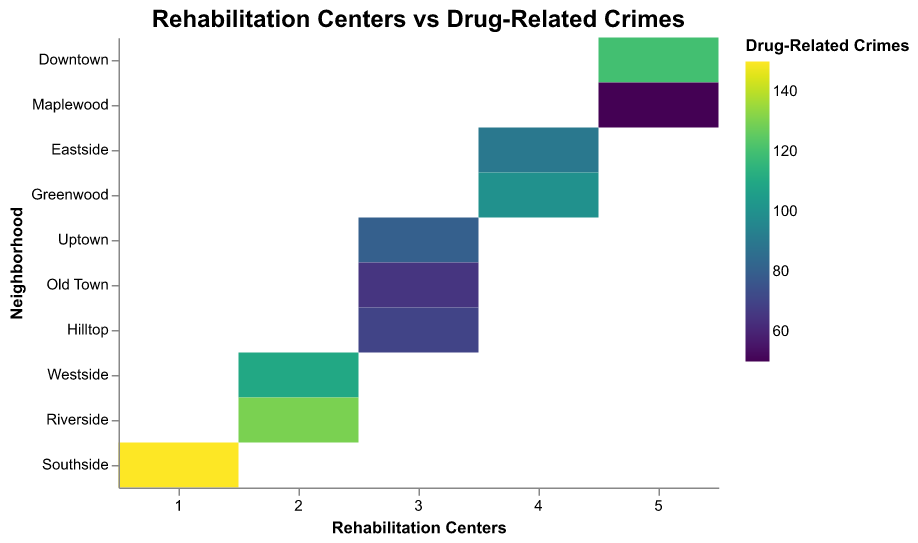what is the title of the heatmap? The title is displayed at the top of the heatmap and is centered. It provides the overarching theme or the main focus of the heatmap.
Answer: Rehabilitation Centers vs Drug-Related Crimes Which neighborhood has the highest number of rehabilitation centers? By referring to the y-axis representing neighborhoods and the x-axis indicating the number of rehabilitation centers, we see the highest value.
Answer: Downtown and Maplewood, each with 5 centers What is the color legend about? The color legend shows the gradient used in the heatmap to represent the range of drug-related crimes, with different shades indicating varying crime rates.
Answer: Drug-Related Crimes How many neighborhoods have exactly 3 rehabilitation centers? By examining the neighborhoods column and counting those with three rehabilitation centers, which can easily be seen on the x-axis, we can determine the number.
Answer: 3 (Uptown, Old Town, and Hilltop) Which neighborhoods have more than 100 drug-related crimes? By identifying the color intensity on the heatmap representing high crime rates and cross-referencing with the y-axis for neighborhood names, we find the neighborhoods with high crime rates.
Answer: Downtown, Westside, Southside, Riverside Does having more rehabilitation centers correlate with fewer drug-related crimes? Observing the heatmap, one can compare neighborhoods with higher numbers of centers and their respective crime rates to judge correlations. For example, Downtown and Maplewood have high and low crime rates respectively despite having the same number of rehabilitation centers.
Answer: No clear correlation What's the difference in drug-related crime numbers between Riverside and Hilltop? Locate Riverside and Hilltop on the y-axis and refer to their corresponding crime rates on the color scale. The subtraction of these values provides the difference.
Answer: 130 - 70 = 60 Which neighborhood with exactly 2 rehabilitation centers has the highest crime rate? By locating neighborhoods with 2 rehabilitation centers on the x-axis and then identifying the neighborhood with the darkest corresponding color tone on the heatmap, we determine the highest crime rate.
Answer: Riverside What seems to be the general trend regarding rehabilitation centers and drug-related crimes? By observing the overall heatmap, one can infer whether there are any trends such as an increase or decrease in crime rates with more rehabilitation centers in the neighborhood. The analysis shows mixed results.
Answer: Mixed results Is there any outlier in terms of extremely low drug-related crimes? If so, which neighborhood? The color legend helps identify the lightest shade representing the lowest crime rates, and by matching it to the neighborhoods on the y-axis, we identify the outlier.
Answer: Maplewood 